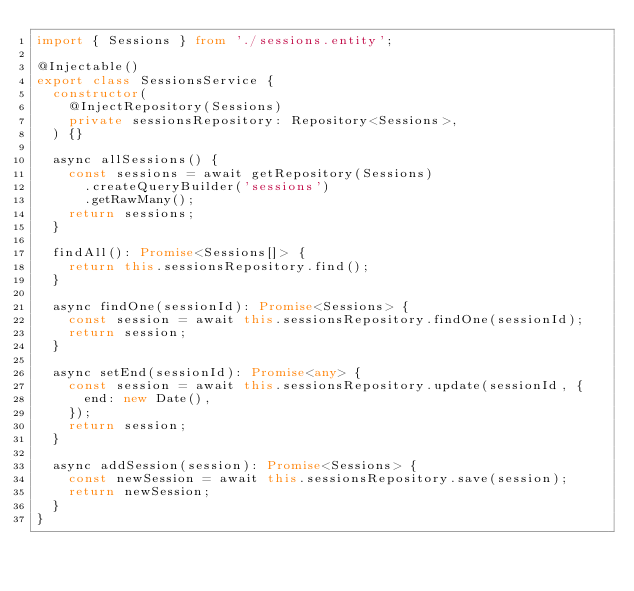<code> <loc_0><loc_0><loc_500><loc_500><_TypeScript_>import { Sessions } from './sessions.entity';

@Injectable()
export class SessionsService {
  constructor(
    @InjectRepository(Sessions)
    private sessionsRepository: Repository<Sessions>,
  ) {}

  async allSessions() {
    const sessions = await getRepository(Sessions)
      .createQueryBuilder('sessions')
      .getRawMany();
    return sessions;
  }

  findAll(): Promise<Sessions[]> {
    return this.sessionsRepository.find();
  }

  async findOne(sessionId): Promise<Sessions> {
    const session = await this.sessionsRepository.findOne(sessionId);
    return session;
  }

  async setEnd(sessionId): Promise<any> {
    const session = await this.sessionsRepository.update(sessionId, {
      end: new Date(),
    });
    return session;
  }

  async addSession(session): Promise<Sessions> {
    const newSession = await this.sessionsRepository.save(session);
    return newSession;
  }
}
</code> 